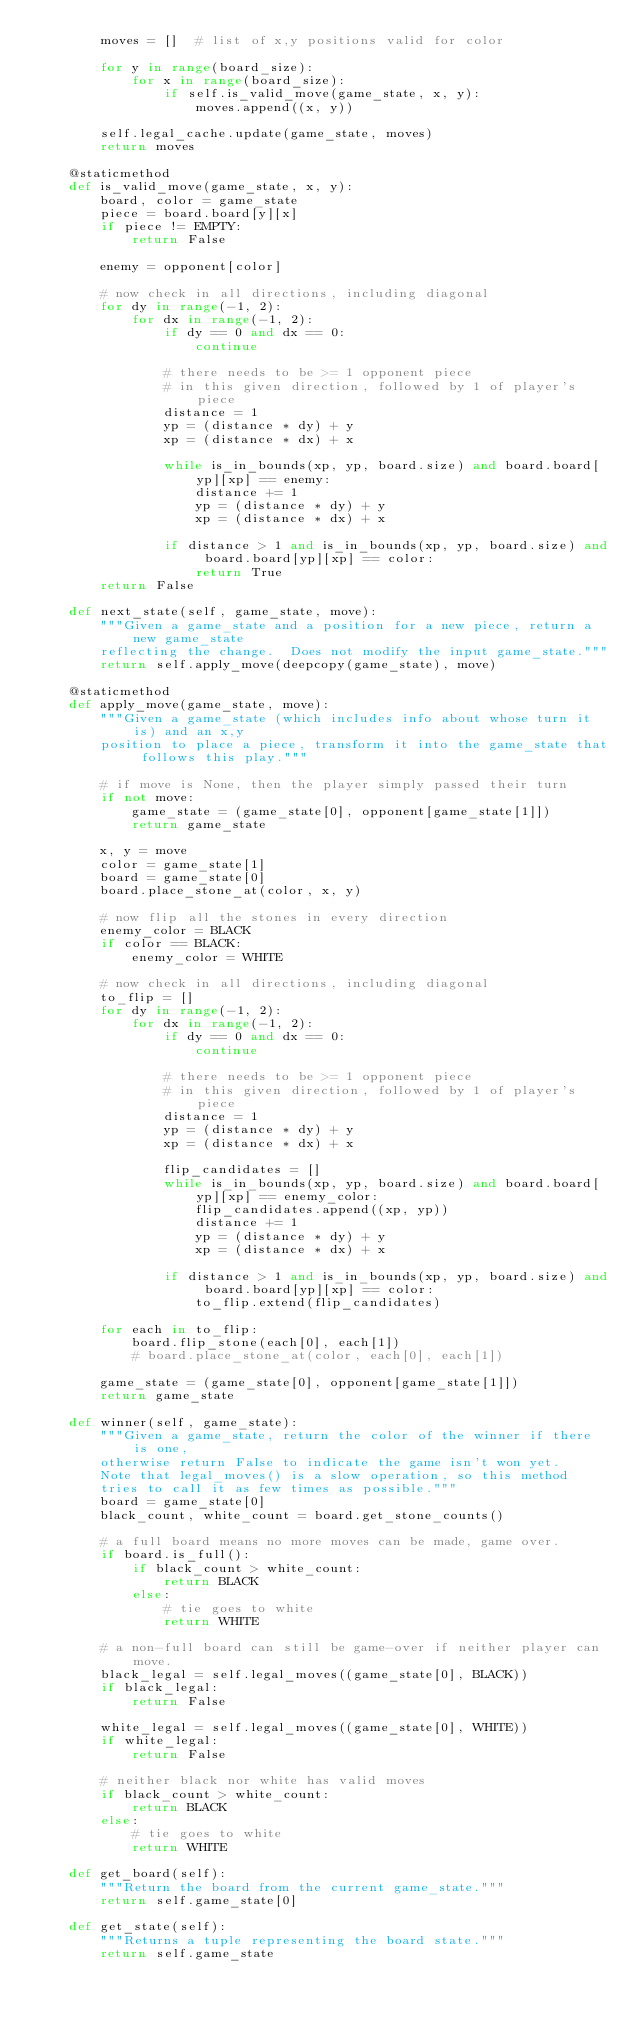Convert code to text. <code><loc_0><loc_0><loc_500><loc_500><_Python_>        moves = []  # list of x,y positions valid for color

        for y in range(board_size):
            for x in range(board_size):
                if self.is_valid_move(game_state, x, y):
                    moves.append((x, y))

        self.legal_cache.update(game_state, moves)
        return moves

    @staticmethod
    def is_valid_move(game_state, x, y):
        board, color = game_state
        piece = board.board[y][x]
        if piece != EMPTY:
            return False

        enemy = opponent[color]

        # now check in all directions, including diagonal
        for dy in range(-1, 2):
            for dx in range(-1, 2):
                if dy == 0 and dx == 0:
                    continue

                # there needs to be >= 1 opponent piece
                # in this given direction, followed by 1 of player's piece
                distance = 1
                yp = (distance * dy) + y
                xp = (distance * dx) + x

                while is_in_bounds(xp, yp, board.size) and board.board[yp][xp] == enemy:
                    distance += 1
                    yp = (distance * dy) + y
                    xp = (distance * dx) + x

                if distance > 1 and is_in_bounds(xp, yp, board.size) and board.board[yp][xp] == color:
                    return True
        return False

    def next_state(self, game_state, move):
        """Given a game_state and a position for a new piece, return a new game_state
        reflecting the change.  Does not modify the input game_state."""
        return self.apply_move(deepcopy(game_state), move)

    @staticmethod
    def apply_move(game_state, move):
        """Given a game_state (which includes info about whose turn it is) and an x,y
        position to place a piece, transform it into the game_state that follows this play."""

        # if move is None, then the player simply passed their turn
        if not move:
            game_state = (game_state[0], opponent[game_state[1]])
            return game_state

        x, y = move
        color = game_state[1]
        board = game_state[0]
        board.place_stone_at(color, x, y)

        # now flip all the stones in every direction
        enemy_color = BLACK
        if color == BLACK:
            enemy_color = WHITE

        # now check in all directions, including diagonal
        to_flip = []
        for dy in range(-1, 2):
            for dx in range(-1, 2):
                if dy == 0 and dx == 0:
                    continue

                # there needs to be >= 1 opponent piece
                # in this given direction, followed by 1 of player's piece
                distance = 1
                yp = (distance * dy) + y
                xp = (distance * dx) + x

                flip_candidates = []
                while is_in_bounds(xp, yp, board.size) and board.board[yp][xp] == enemy_color:
                    flip_candidates.append((xp, yp))
                    distance += 1
                    yp = (distance * dy) + y
                    xp = (distance * dx) + x

                if distance > 1 and is_in_bounds(xp, yp, board.size) and board.board[yp][xp] == color:
                    to_flip.extend(flip_candidates)

        for each in to_flip:
            board.flip_stone(each[0], each[1])
            # board.place_stone_at(color, each[0], each[1])

        game_state = (game_state[0], opponent[game_state[1]])
        return game_state

    def winner(self, game_state):
        """Given a game_state, return the color of the winner if there is one,
        otherwise return False to indicate the game isn't won yet.
        Note that legal_moves() is a slow operation, so this method
        tries to call it as few times as possible."""
        board = game_state[0]
        black_count, white_count = board.get_stone_counts()

        # a full board means no more moves can be made, game over.
        if board.is_full():
            if black_count > white_count:
                return BLACK
            else:
                # tie goes to white
                return WHITE

        # a non-full board can still be game-over if neither player can move.
        black_legal = self.legal_moves((game_state[0], BLACK))
        if black_legal:
            return False

        white_legal = self.legal_moves((game_state[0], WHITE))
        if white_legal:
            return False

        # neither black nor white has valid moves
        if black_count > white_count:
            return BLACK
        else:
            # tie goes to white
            return WHITE

    def get_board(self):
        """Return the board from the current game_state."""
        return self.game_state[0]

    def get_state(self):
        """Returns a tuple representing the board state."""
        return self.game_state
</code> 